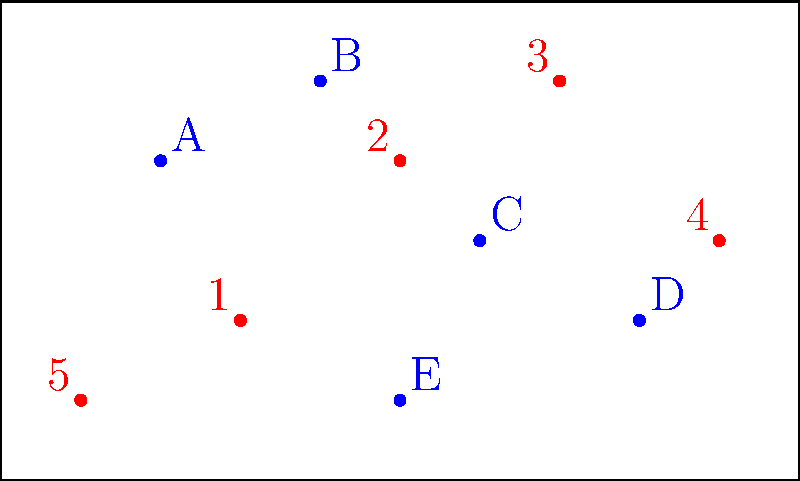Analyze the overhead image of a water polo pool showing player positions. Which machine learning technique would be most appropriate for identifying and classifying team formation patterns based on this type of data? To identify and classify team formation patterns from overhead pool images, we need to consider the following steps:

1. Data representation: The image shows player positions as points in a 2D space, with different colors representing different teams.

2. Pattern recognition: We need to identify spatial relationships between players and recognize overall team formations.

3. Classification: The goal is to classify different formations into distinct categories.

4. Handling variability: Player positions may vary slightly within the same formation type.

5. Multiple instances: We would need many such images to train a model effectively.

Considering these factors, the most appropriate machine learning technique would be Convolutional Neural Networks (CNNs) for the following reasons:

a) CNNs are excellent at processing 2D spatial data, which is exactly what we have in these overhead images.

b) They can automatically learn and detect important features and patterns in the data, such as the relative positions of players.

c) CNNs are translation-invariant, meaning they can recognize patterns regardless of where they appear in the image.

d) With proper training data, CNNs can learn to classify different formation types despite small variations in player positions.

e) CNNs can handle raw image data directly, eliminating the need for manual feature extraction.

f) They have shown superior performance in image classification tasks across various domains.

While other techniques like clustering algorithms (e.g., k-means) or support vector machines could be used, they would require more manual feature engineering and may not capture the spatial relationships as effectively as CNNs.
Answer: Convolutional Neural Networks (CNNs) 